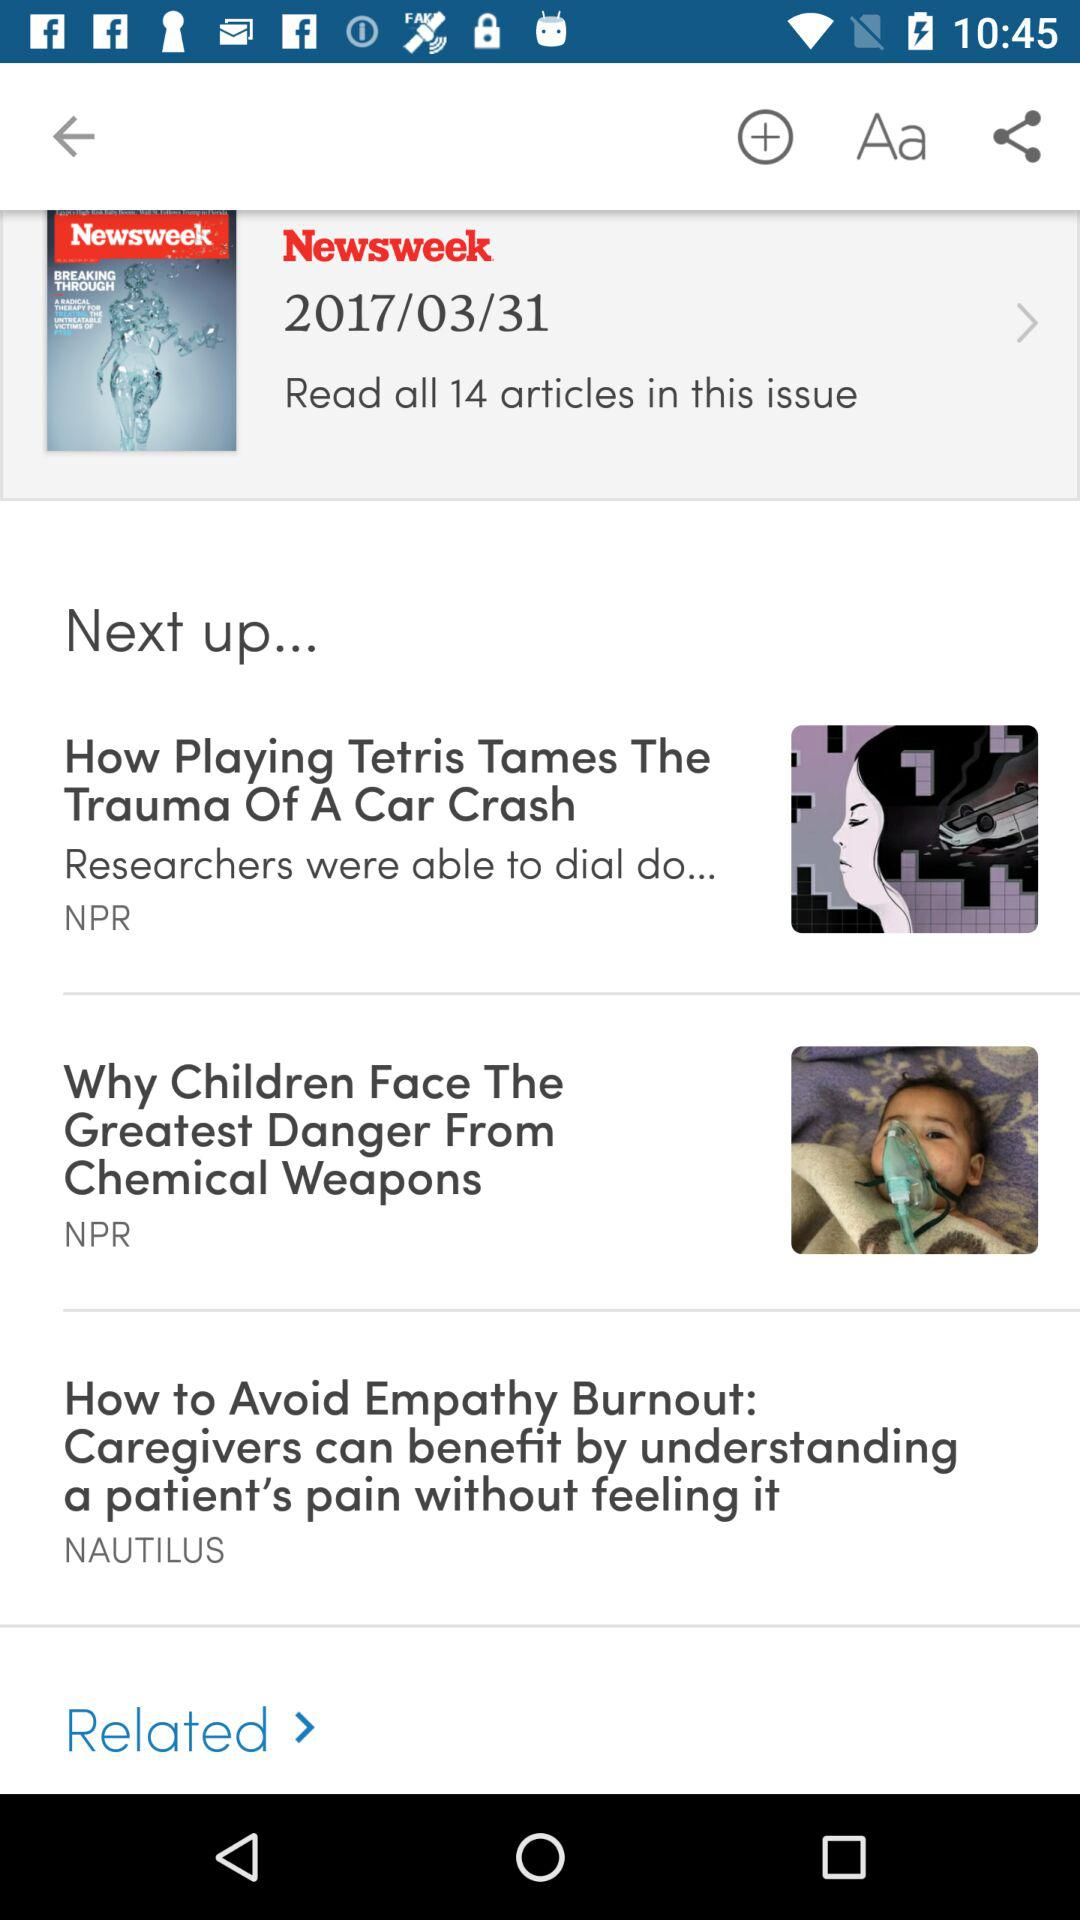How many of the articles are from NPR?
Answer the question using a single word or phrase. 2 